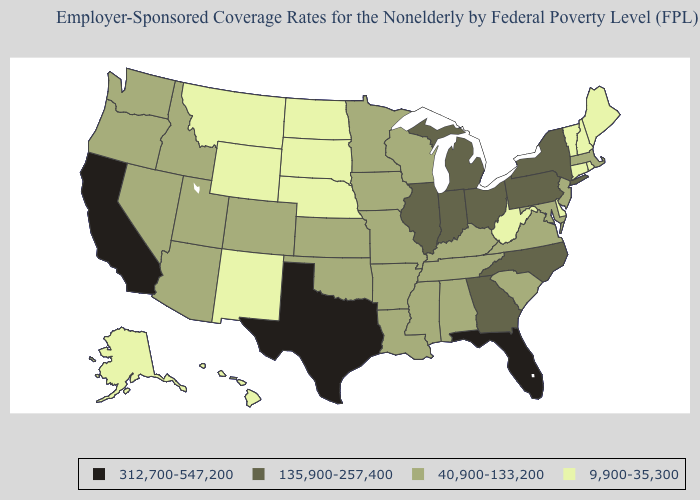Among the states that border Wyoming , which have the highest value?
Give a very brief answer. Colorado, Idaho, Utah. What is the lowest value in the West?
Write a very short answer. 9,900-35,300. What is the highest value in the USA?
Be succinct. 312,700-547,200. Among the states that border Wisconsin , which have the highest value?
Be succinct. Illinois, Michigan. What is the highest value in the Northeast ?
Give a very brief answer. 135,900-257,400. Does Delaware have the highest value in the South?
Keep it brief. No. Does Delaware have the lowest value in the USA?
Write a very short answer. Yes. What is the lowest value in the USA?
Short answer required. 9,900-35,300. Name the states that have a value in the range 9,900-35,300?
Short answer required. Alaska, Connecticut, Delaware, Hawaii, Maine, Montana, Nebraska, New Hampshire, New Mexico, North Dakota, Rhode Island, South Dakota, Vermont, West Virginia, Wyoming. Which states have the highest value in the USA?
Short answer required. California, Florida, Texas. Among the states that border Washington , which have the highest value?
Concise answer only. Idaho, Oregon. Among the states that border Delaware , does Pennsylvania have the lowest value?
Quick response, please. No. What is the lowest value in states that border Pennsylvania?
Short answer required. 9,900-35,300. Does the map have missing data?
Write a very short answer. No. Is the legend a continuous bar?
Write a very short answer. No. 